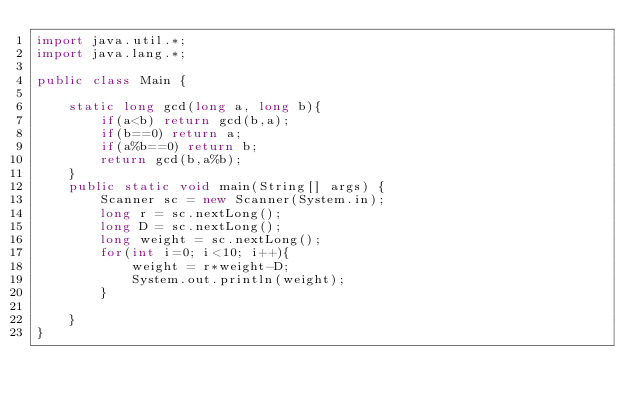Convert code to text. <code><loc_0><loc_0><loc_500><loc_500><_Java_>import java.util.*;
import java.lang.*;

public class Main {

    static long gcd(long a, long b){
        if(a<b) return gcd(b,a);
        if(b==0) return a;
        if(a%b==0) return b;
        return gcd(b,a%b);
    }
    public static void main(String[] args) {
        Scanner sc = new Scanner(System.in);
        long r = sc.nextLong();
        long D = sc.nextLong();
        long weight = sc.nextLong();
        for(int i=0; i<10; i++){
            weight = r*weight-D;
            System.out.println(weight);
        }

    }
}</code> 